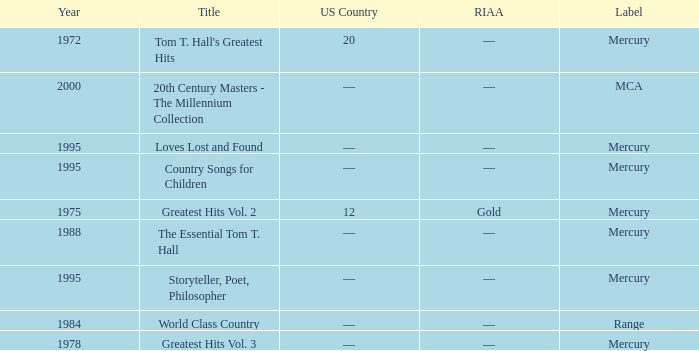What is the title of the album that had a RIAA of gold? Greatest Hits Vol. 2. 